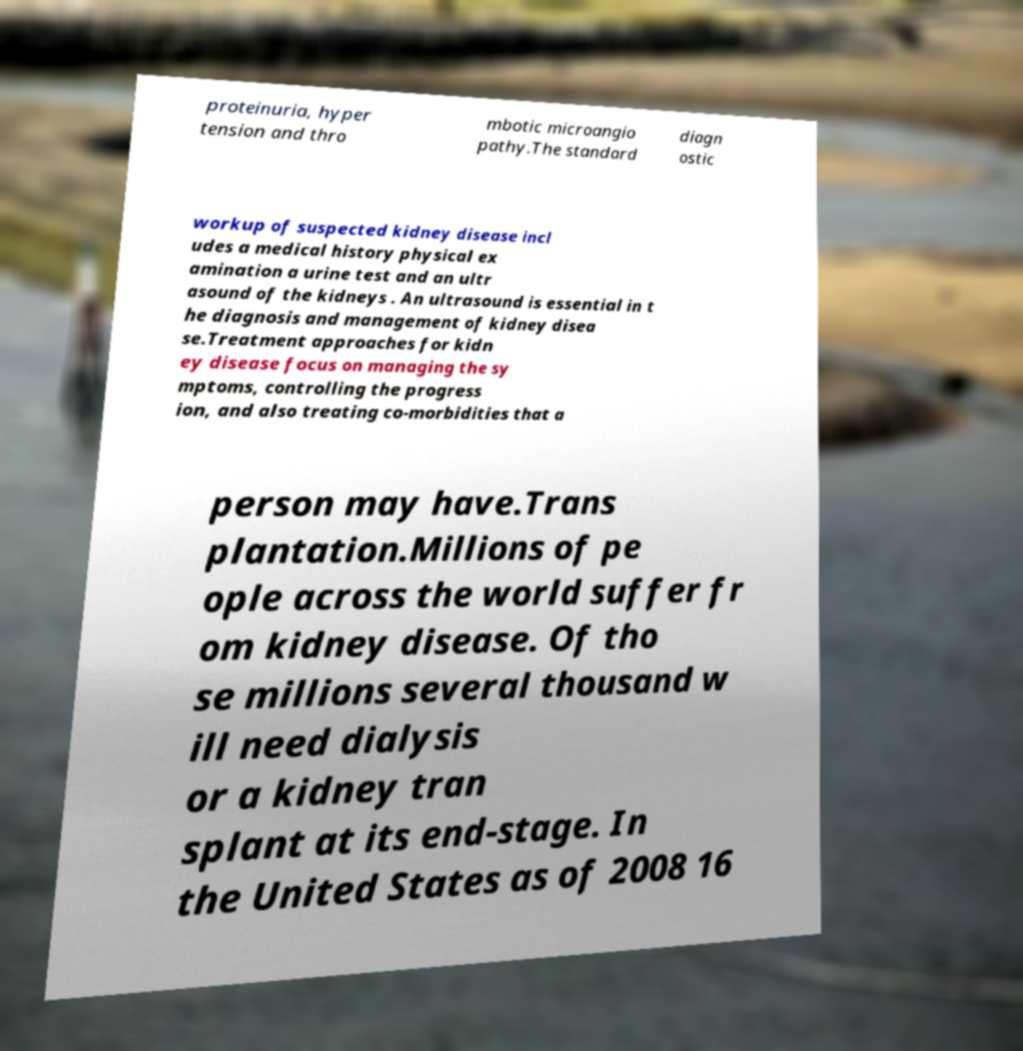Please identify and transcribe the text found in this image. proteinuria, hyper tension and thro mbotic microangio pathy.The standard diagn ostic workup of suspected kidney disease incl udes a medical history physical ex amination a urine test and an ultr asound of the kidneys . An ultrasound is essential in t he diagnosis and management of kidney disea se.Treatment approaches for kidn ey disease focus on managing the sy mptoms, controlling the progress ion, and also treating co-morbidities that a person may have.Trans plantation.Millions of pe ople across the world suffer fr om kidney disease. Of tho se millions several thousand w ill need dialysis or a kidney tran splant at its end-stage. In the United States as of 2008 16 